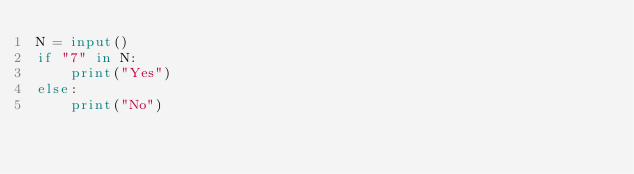<code> <loc_0><loc_0><loc_500><loc_500><_Python_>N = input()
if "7" in N:
    print("Yes")
else:
    print("No")</code> 